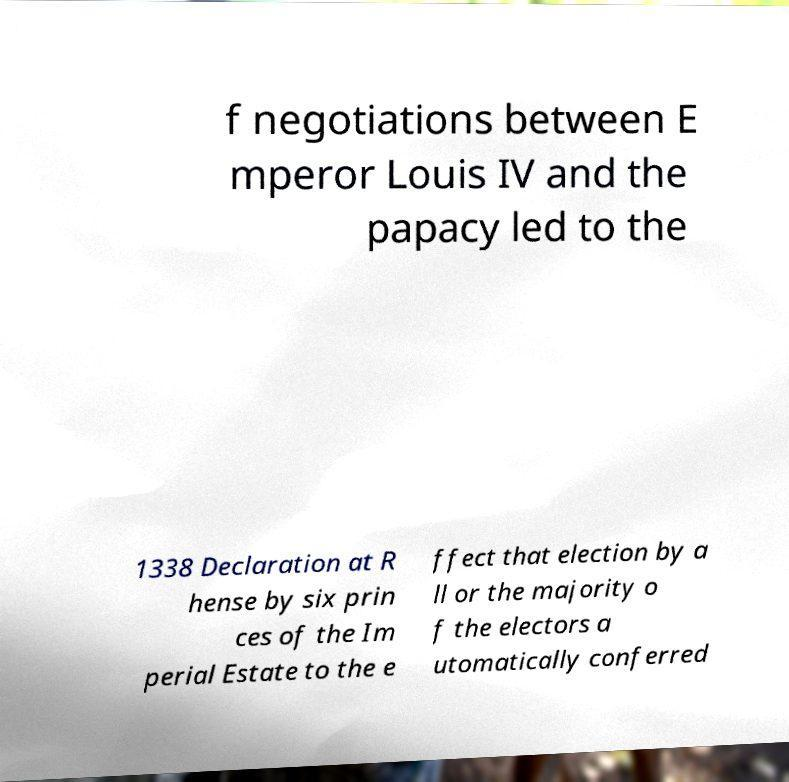What messages or text are displayed in this image? I need them in a readable, typed format. f negotiations between E mperor Louis IV and the papacy led to the 1338 Declaration at R hense by six prin ces of the Im perial Estate to the e ffect that election by a ll or the majority o f the electors a utomatically conferred 